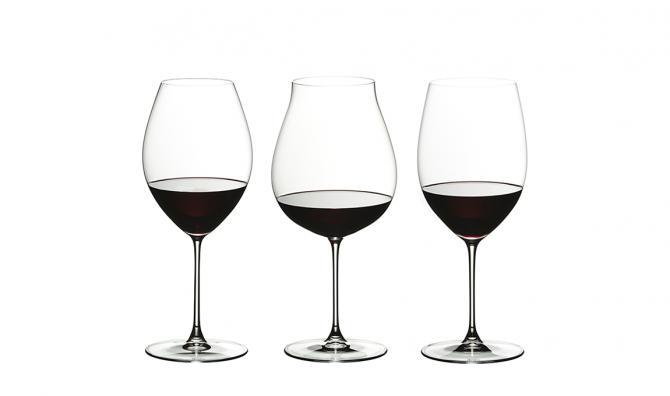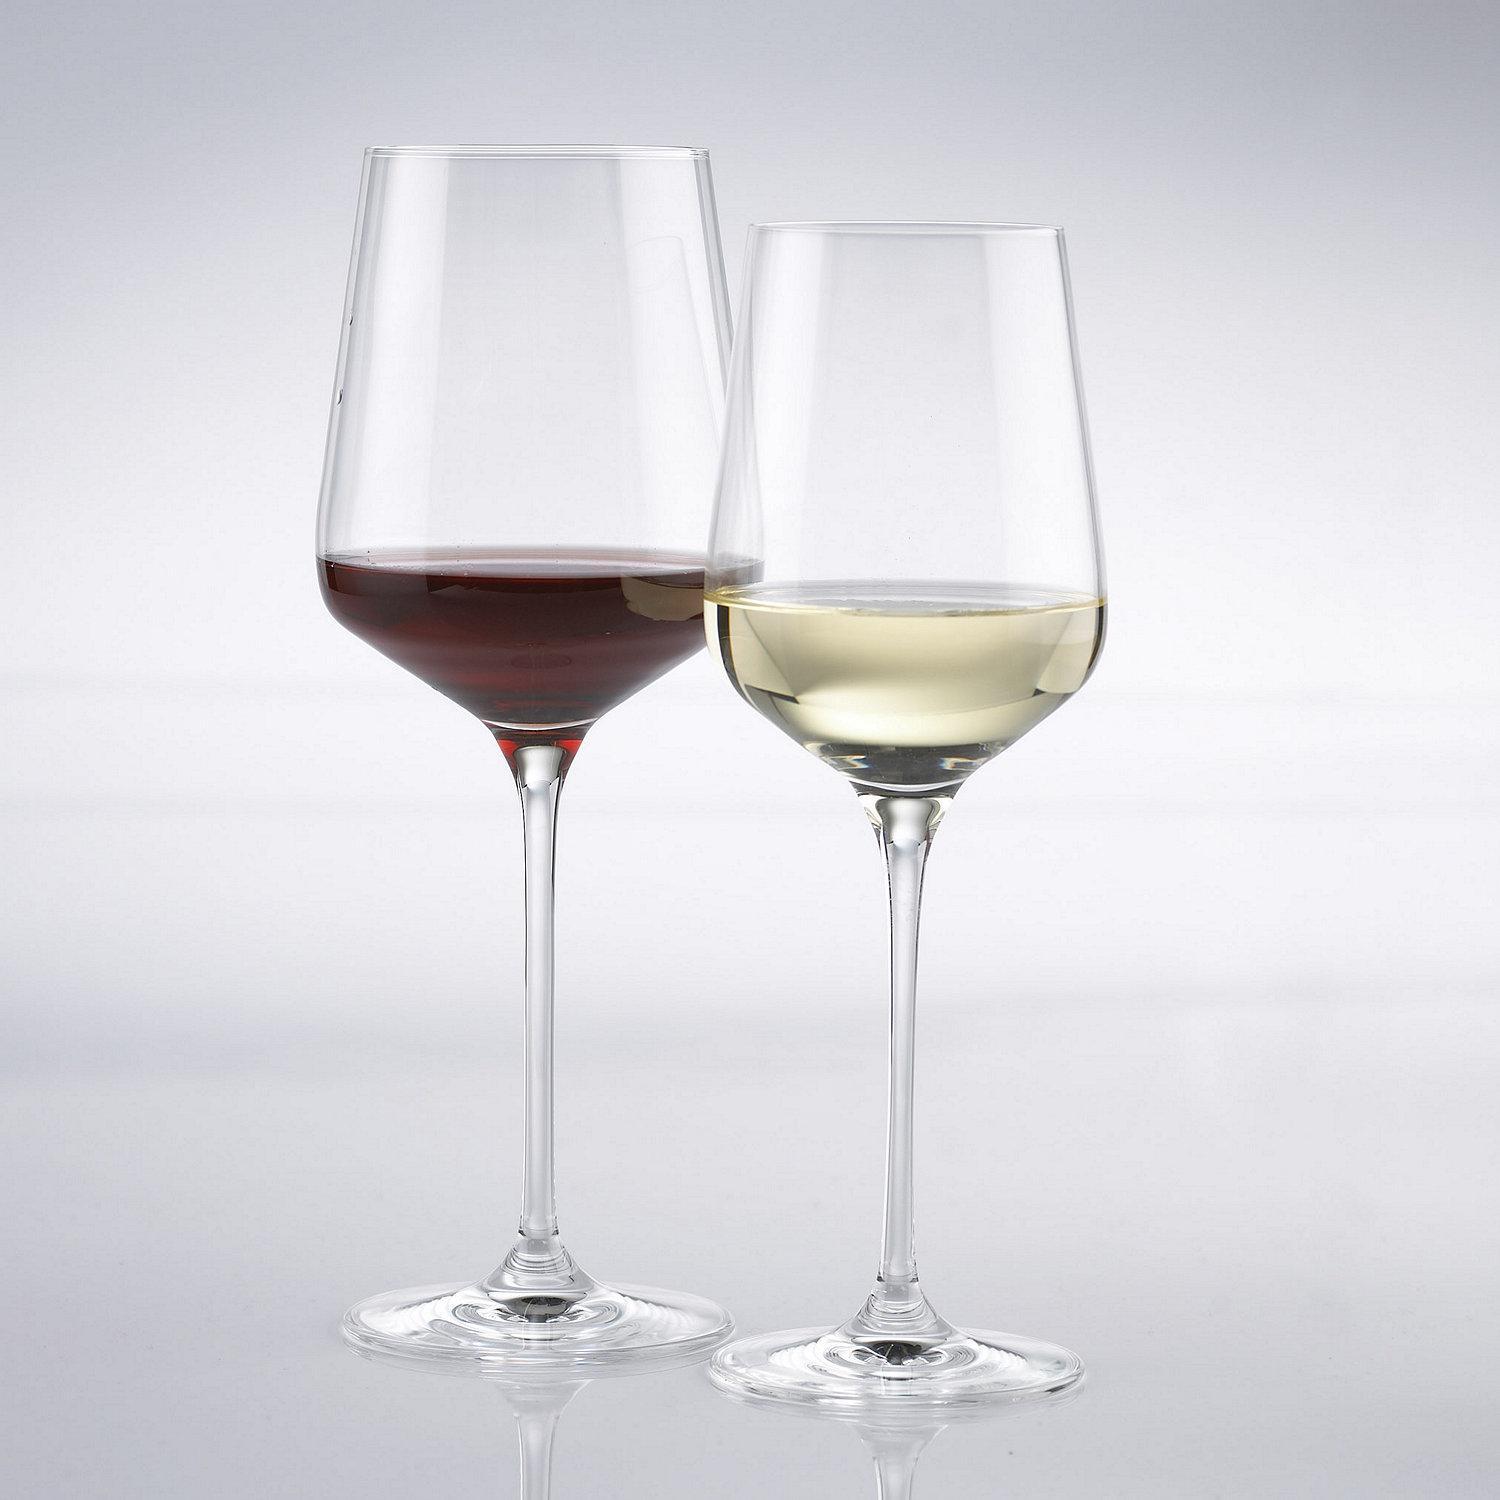The first image is the image on the left, the second image is the image on the right. Given the left and right images, does the statement "In the left image, there is one glass of red wine and three empty wine glasses" hold true? Answer yes or no. No. The first image is the image on the left, the second image is the image on the right. Assess this claim about the two images: "In one image, two glasses are right next to each other, and in the other, four glasses are arranged so some are in front of others.". Correct or not? Answer yes or no. No. 